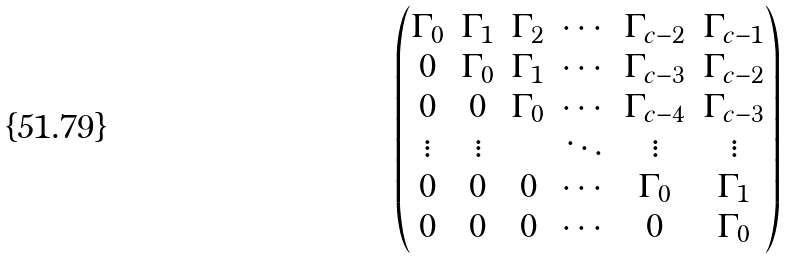Convert formula to latex. <formula><loc_0><loc_0><loc_500><loc_500>\begin{pmatrix} \Gamma _ { 0 } & \Gamma _ { 1 } & \Gamma _ { 2 } & \cdots & \Gamma _ { c - 2 } & \Gamma _ { c - 1 } \\ 0 & \Gamma _ { 0 } & \Gamma _ { 1 } & \cdots & \Gamma _ { c - 3 } & \Gamma _ { c - 2 } \\ 0 & 0 & \Gamma _ { 0 } & \cdots & \Gamma _ { c - 4 } & \Gamma _ { c - 3 } \\ \vdots & \vdots & & \ddots & \vdots & \vdots \\ 0 & 0 & 0 & \cdots & \Gamma _ { 0 } & \Gamma _ { 1 } \\ 0 & 0 & 0 & \cdots & 0 & \Gamma _ { 0 } \end{pmatrix}</formula> 